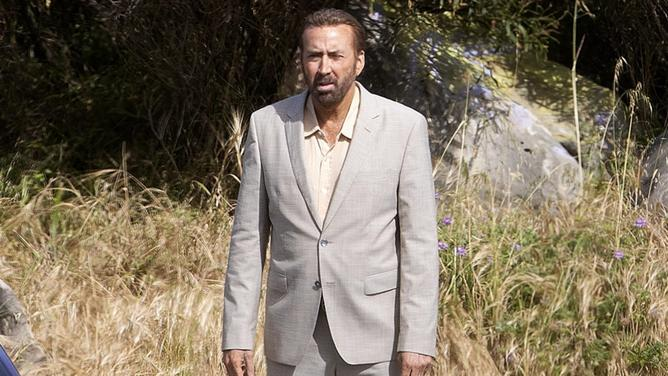What emotions does the character in the image appear to be experiencing? The character seems to be displaying a serious and contemplative demeanor. His focused gaze and slightly furrowed brows suggest a state of serious reflection or concern, possibly indicating his involvement in a tense or critical moment. 